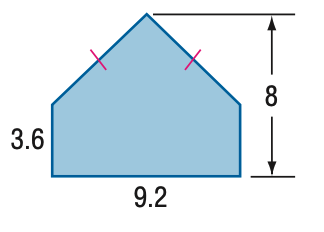Question: Find the area of the figure. Round to the nearest tenth if necessary.
Choices:
A. 52.4
B. 53.4
C. 57.6
D. 73.6
Answer with the letter. Answer: B 